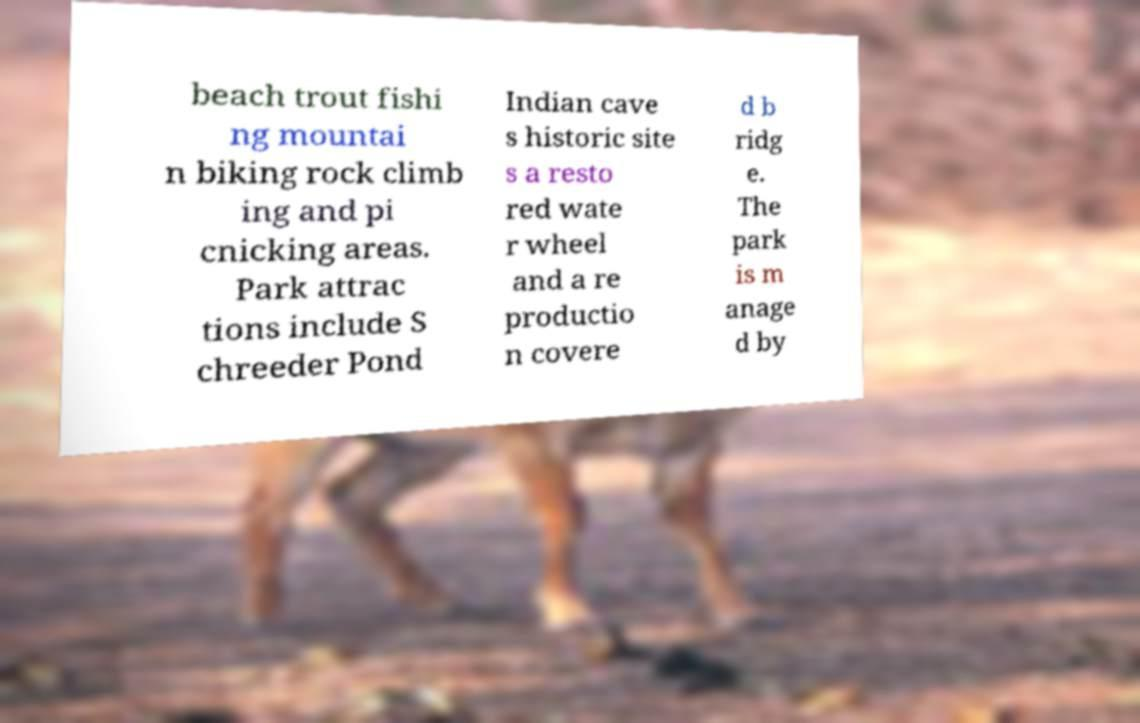For documentation purposes, I need the text within this image transcribed. Could you provide that? beach trout fishi ng mountai n biking rock climb ing and pi cnicking areas. Park attrac tions include S chreeder Pond Indian cave s historic site s a resto red wate r wheel and a re productio n covere d b ridg e. The park is m anage d by 